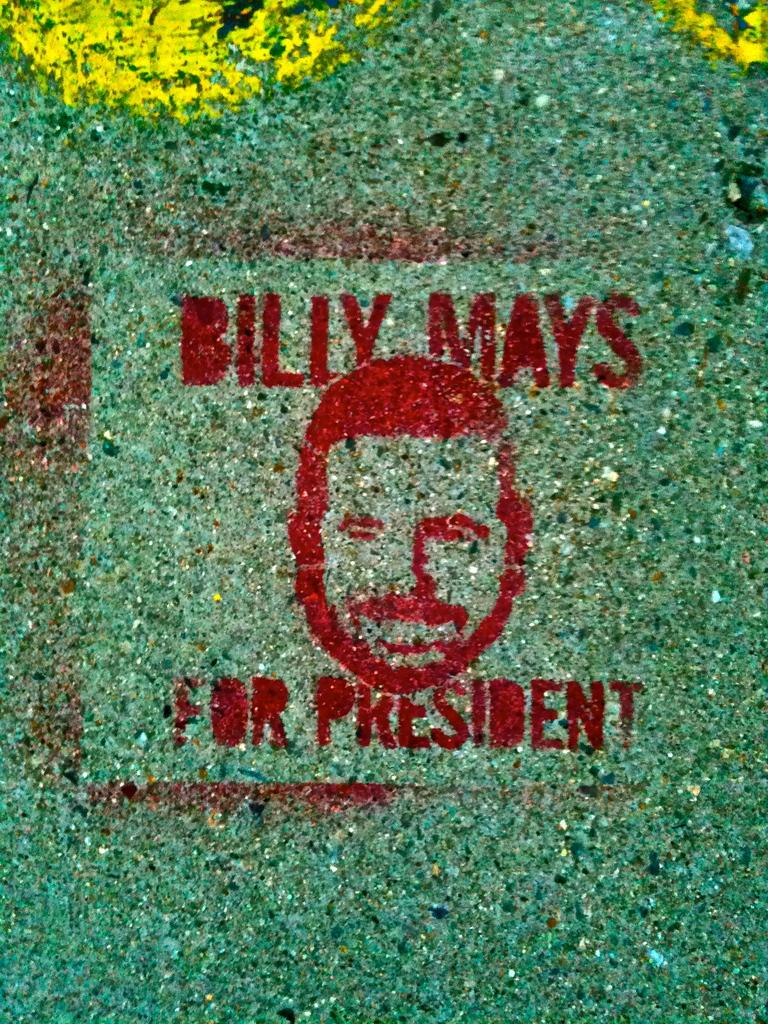What can be found in the image that contains written information? There is text in the image. What type of artwork is present in the image? There is a painting of a person's face in the image. What type of ray can be seen swimming in the image? There is no ray present in the image; it only contains text and a painting of a person's face. How many coils are visible in the image? There are no coils present in the image. 